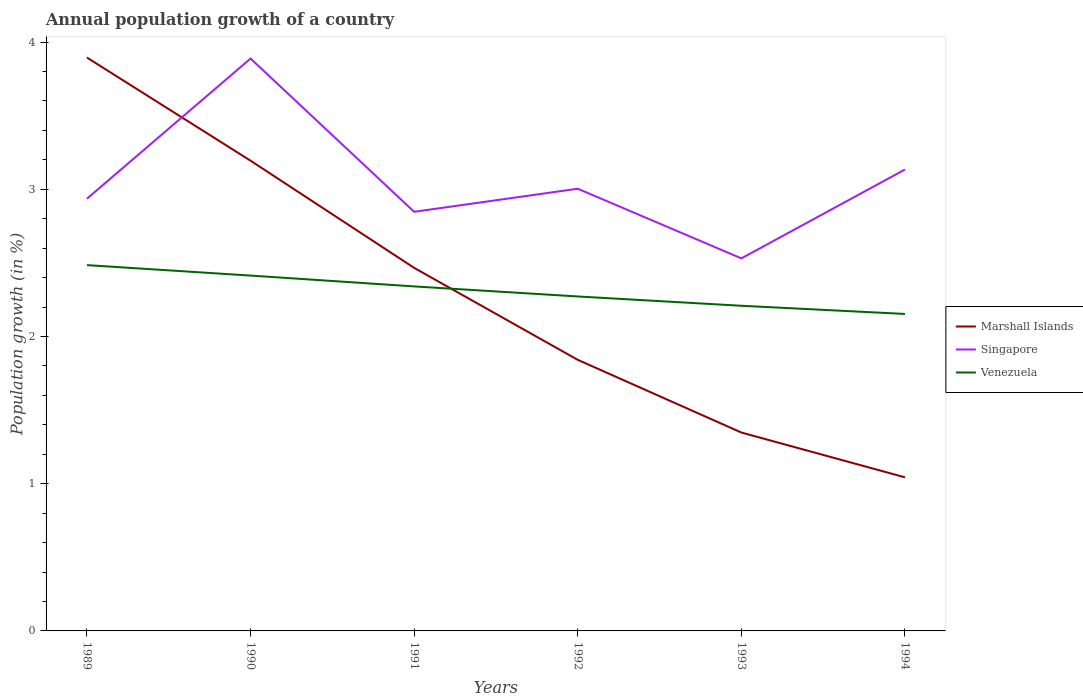Does the line corresponding to Marshall Islands intersect with the line corresponding to Venezuela?
Your response must be concise. Yes. Across all years, what is the maximum annual population growth in Marshall Islands?
Give a very brief answer. 1.04. What is the total annual population growth in Marshall Islands in the graph?
Your response must be concise. 1.12. What is the difference between the highest and the second highest annual population growth in Singapore?
Your answer should be compact. 1.36. What is the difference between the highest and the lowest annual population growth in Marshall Islands?
Your answer should be very brief. 3. How many lines are there?
Provide a succinct answer. 3. What is the difference between two consecutive major ticks on the Y-axis?
Your answer should be compact. 1. Does the graph contain any zero values?
Give a very brief answer. No. Where does the legend appear in the graph?
Your answer should be compact. Center right. What is the title of the graph?
Ensure brevity in your answer.  Annual population growth of a country. Does "Least developed countries" appear as one of the legend labels in the graph?
Offer a very short reply. No. What is the label or title of the X-axis?
Your answer should be very brief. Years. What is the label or title of the Y-axis?
Offer a terse response. Population growth (in %). What is the Population growth (in %) of Marshall Islands in 1989?
Make the answer very short. 3.89. What is the Population growth (in %) in Singapore in 1989?
Your answer should be compact. 2.94. What is the Population growth (in %) in Venezuela in 1989?
Offer a very short reply. 2.48. What is the Population growth (in %) in Marshall Islands in 1990?
Your answer should be compact. 3.19. What is the Population growth (in %) of Singapore in 1990?
Provide a succinct answer. 3.89. What is the Population growth (in %) in Venezuela in 1990?
Your response must be concise. 2.41. What is the Population growth (in %) in Marshall Islands in 1991?
Make the answer very short. 2.47. What is the Population growth (in %) of Singapore in 1991?
Provide a succinct answer. 2.85. What is the Population growth (in %) of Venezuela in 1991?
Provide a succinct answer. 2.34. What is the Population growth (in %) in Marshall Islands in 1992?
Offer a terse response. 1.84. What is the Population growth (in %) in Singapore in 1992?
Provide a succinct answer. 3. What is the Population growth (in %) in Venezuela in 1992?
Your answer should be very brief. 2.27. What is the Population growth (in %) of Marshall Islands in 1993?
Provide a short and direct response. 1.35. What is the Population growth (in %) in Singapore in 1993?
Your response must be concise. 2.53. What is the Population growth (in %) of Venezuela in 1993?
Provide a short and direct response. 2.21. What is the Population growth (in %) of Marshall Islands in 1994?
Offer a very short reply. 1.04. What is the Population growth (in %) of Singapore in 1994?
Keep it short and to the point. 3.13. What is the Population growth (in %) of Venezuela in 1994?
Your answer should be compact. 2.15. Across all years, what is the maximum Population growth (in %) of Marshall Islands?
Give a very brief answer. 3.89. Across all years, what is the maximum Population growth (in %) in Singapore?
Provide a succinct answer. 3.89. Across all years, what is the maximum Population growth (in %) of Venezuela?
Provide a succinct answer. 2.48. Across all years, what is the minimum Population growth (in %) of Marshall Islands?
Make the answer very short. 1.04. Across all years, what is the minimum Population growth (in %) of Singapore?
Keep it short and to the point. 2.53. Across all years, what is the minimum Population growth (in %) in Venezuela?
Provide a succinct answer. 2.15. What is the total Population growth (in %) in Marshall Islands in the graph?
Make the answer very short. 13.79. What is the total Population growth (in %) in Singapore in the graph?
Make the answer very short. 18.34. What is the total Population growth (in %) in Venezuela in the graph?
Your answer should be very brief. 13.87. What is the difference between the Population growth (in %) in Marshall Islands in 1989 and that in 1990?
Make the answer very short. 0.7. What is the difference between the Population growth (in %) of Singapore in 1989 and that in 1990?
Provide a succinct answer. -0.95. What is the difference between the Population growth (in %) in Venezuela in 1989 and that in 1990?
Make the answer very short. 0.07. What is the difference between the Population growth (in %) of Marshall Islands in 1989 and that in 1991?
Give a very brief answer. 1.43. What is the difference between the Population growth (in %) of Singapore in 1989 and that in 1991?
Keep it short and to the point. 0.09. What is the difference between the Population growth (in %) in Venezuela in 1989 and that in 1991?
Provide a short and direct response. 0.14. What is the difference between the Population growth (in %) of Marshall Islands in 1989 and that in 1992?
Your answer should be very brief. 2.05. What is the difference between the Population growth (in %) of Singapore in 1989 and that in 1992?
Provide a short and direct response. -0.07. What is the difference between the Population growth (in %) of Venezuela in 1989 and that in 1992?
Your answer should be very brief. 0.21. What is the difference between the Population growth (in %) of Marshall Islands in 1989 and that in 1993?
Keep it short and to the point. 2.55. What is the difference between the Population growth (in %) of Singapore in 1989 and that in 1993?
Offer a terse response. 0.41. What is the difference between the Population growth (in %) of Venezuela in 1989 and that in 1993?
Keep it short and to the point. 0.28. What is the difference between the Population growth (in %) of Marshall Islands in 1989 and that in 1994?
Your answer should be very brief. 2.85. What is the difference between the Population growth (in %) in Singapore in 1989 and that in 1994?
Your answer should be compact. -0.2. What is the difference between the Population growth (in %) of Venezuela in 1989 and that in 1994?
Provide a short and direct response. 0.33. What is the difference between the Population growth (in %) of Marshall Islands in 1990 and that in 1991?
Provide a succinct answer. 0.73. What is the difference between the Population growth (in %) of Singapore in 1990 and that in 1991?
Give a very brief answer. 1.04. What is the difference between the Population growth (in %) in Venezuela in 1990 and that in 1991?
Ensure brevity in your answer.  0.07. What is the difference between the Population growth (in %) of Marshall Islands in 1990 and that in 1992?
Your answer should be compact. 1.35. What is the difference between the Population growth (in %) of Singapore in 1990 and that in 1992?
Keep it short and to the point. 0.88. What is the difference between the Population growth (in %) of Venezuela in 1990 and that in 1992?
Ensure brevity in your answer.  0.14. What is the difference between the Population growth (in %) of Marshall Islands in 1990 and that in 1993?
Give a very brief answer. 1.85. What is the difference between the Population growth (in %) of Singapore in 1990 and that in 1993?
Provide a short and direct response. 1.36. What is the difference between the Population growth (in %) in Venezuela in 1990 and that in 1993?
Offer a terse response. 0.21. What is the difference between the Population growth (in %) in Marshall Islands in 1990 and that in 1994?
Offer a very short reply. 2.15. What is the difference between the Population growth (in %) of Singapore in 1990 and that in 1994?
Give a very brief answer. 0.75. What is the difference between the Population growth (in %) of Venezuela in 1990 and that in 1994?
Provide a short and direct response. 0.26. What is the difference between the Population growth (in %) in Marshall Islands in 1991 and that in 1992?
Offer a terse response. 0.62. What is the difference between the Population growth (in %) in Singapore in 1991 and that in 1992?
Provide a succinct answer. -0.16. What is the difference between the Population growth (in %) of Venezuela in 1991 and that in 1992?
Make the answer very short. 0.07. What is the difference between the Population growth (in %) in Marshall Islands in 1991 and that in 1993?
Provide a short and direct response. 1.12. What is the difference between the Population growth (in %) in Singapore in 1991 and that in 1993?
Your answer should be compact. 0.32. What is the difference between the Population growth (in %) in Venezuela in 1991 and that in 1993?
Your answer should be very brief. 0.13. What is the difference between the Population growth (in %) of Marshall Islands in 1991 and that in 1994?
Make the answer very short. 1.42. What is the difference between the Population growth (in %) in Singapore in 1991 and that in 1994?
Give a very brief answer. -0.29. What is the difference between the Population growth (in %) in Venezuela in 1991 and that in 1994?
Offer a very short reply. 0.19. What is the difference between the Population growth (in %) of Marshall Islands in 1992 and that in 1993?
Your response must be concise. 0.49. What is the difference between the Population growth (in %) of Singapore in 1992 and that in 1993?
Your answer should be very brief. 0.47. What is the difference between the Population growth (in %) in Venezuela in 1992 and that in 1993?
Keep it short and to the point. 0.06. What is the difference between the Population growth (in %) in Marshall Islands in 1992 and that in 1994?
Give a very brief answer. 0.8. What is the difference between the Population growth (in %) in Singapore in 1992 and that in 1994?
Make the answer very short. -0.13. What is the difference between the Population growth (in %) in Venezuela in 1992 and that in 1994?
Your answer should be very brief. 0.12. What is the difference between the Population growth (in %) of Marshall Islands in 1993 and that in 1994?
Ensure brevity in your answer.  0.3. What is the difference between the Population growth (in %) of Singapore in 1993 and that in 1994?
Your answer should be very brief. -0.6. What is the difference between the Population growth (in %) in Venezuela in 1993 and that in 1994?
Provide a short and direct response. 0.06. What is the difference between the Population growth (in %) in Marshall Islands in 1989 and the Population growth (in %) in Singapore in 1990?
Provide a short and direct response. 0.01. What is the difference between the Population growth (in %) of Marshall Islands in 1989 and the Population growth (in %) of Venezuela in 1990?
Your response must be concise. 1.48. What is the difference between the Population growth (in %) in Singapore in 1989 and the Population growth (in %) in Venezuela in 1990?
Offer a very short reply. 0.52. What is the difference between the Population growth (in %) of Marshall Islands in 1989 and the Population growth (in %) of Singapore in 1991?
Your answer should be very brief. 1.05. What is the difference between the Population growth (in %) in Marshall Islands in 1989 and the Population growth (in %) in Venezuela in 1991?
Provide a succinct answer. 1.55. What is the difference between the Population growth (in %) in Singapore in 1989 and the Population growth (in %) in Venezuela in 1991?
Ensure brevity in your answer.  0.6. What is the difference between the Population growth (in %) of Marshall Islands in 1989 and the Population growth (in %) of Singapore in 1992?
Ensure brevity in your answer.  0.89. What is the difference between the Population growth (in %) of Marshall Islands in 1989 and the Population growth (in %) of Venezuela in 1992?
Your answer should be very brief. 1.62. What is the difference between the Population growth (in %) in Singapore in 1989 and the Population growth (in %) in Venezuela in 1992?
Offer a very short reply. 0.66. What is the difference between the Population growth (in %) of Marshall Islands in 1989 and the Population growth (in %) of Singapore in 1993?
Keep it short and to the point. 1.36. What is the difference between the Population growth (in %) in Marshall Islands in 1989 and the Population growth (in %) in Venezuela in 1993?
Offer a very short reply. 1.69. What is the difference between the Population growth (in %) of Singapore in 1989 and the Population growth (in %) of Venezuela in 1993?
Ensure brevity in your answer.  0.73. What is the difference between the Population growth (in %) of Marshall Islands in 1989 and the Population growth (in %) of Singapore in 1994?
Keep it short and to the point. 0.76. What is the difference between the Population growth (in %) in Marshall Islands in 1989 and the Population growth (in %) in Venezuela in 1994?
Offer a terse response. 1.74. What is the difference between the Population growth (in %) of Singapore in 1989 and the Population growth (in %) of Venezuela in 1994?
Your answer should be very brief. 0.78. What is the difference between the Population growth (in %) of Marshall Islands in 1990 and the Population growth (in %) of Singapore in 1991?
Your answer should be compact. 0.35. What is the difference between the Population growth (in %) of Marshall Islands in 1990 and the Population growth (in %) of Venezuela in 1991?
Your answer should be very brief. 0.85. What is the difference between the Population growth (in %) of Singapore in 1990 and the Population growth (in %) of Venezuela in 1991?
Offer a terse response. 1.55. What is the difference between the Population growth (in %) in Marshall Islands in 1990 and the Population growth (in %) in Singapore in 1992?
Provide a short and direct response. 0.19. What is the difference between the Population growth (in %) of Marshall Islands in 1990 and the Population growth (in %) of Venezuela in 1992?
Give a very brief answer. 0.92. What is the difference between the Population growth (in %) of Singapore in 1990 and the Population growth (in %) of Venezuela in 1992?
Ensure brevity in your answer.  1.62. What is the difference between the Population growth (in %) in Marshall Islands in 1990 and the Population growth (in %) in Singapore in 1993?
Keep it short and to the point. 0.66. What is the difference between the Population growth (in %) of Marshall Islands in 1990 and the Population growth (in %) of Venezuela in 1993?
Your answer should be compact. 0.99. What is the difference between the Population growth (in %) in Singapore in 1990 and the Population growth (in %) in Venezuela in 1993?
Your answer should be compact. 1.68. What is the difference between the Population growth (in %) of Marshall Islands in 1990 and the Population growth (in %) of Singapore in 1994?
Offer a terse response. 0.06. What is the difference between the Population growth (in %) of Marshall Islands in 1990 and the Population growth (in %) of Venezuela in 1994?
Your answer should be very brief. 1.04. What is the difference between the Population growth (in %) of Singapore in 1990 and the Population growth (in %) of Venezuela in 1994?
Offer a very short reply. 1.73. What is the difference between the Population growth (in %) of Marshall Islands in 1991 and the Population growth (in %) of Singapore in 1992?
Give a very brief answer. -0.54. What is the difference between the Population growth (in %) in Marshall Islands in 1991 and the Population growth (in %) in Venezuela in 1992?
Your answer should be compact. 0.19. What is the difference between the Population growth (in %) in Singapore in 1991 and the Population growth (in %) in Venezuela in 1992?
Ensure brevity in your answer.  0.58. What is the difference between the Population growth (in %) in Marshall Islands in 1991 and the Population growth (in %) in Singapore in 1993?
Offer a terse response. -0.06. What is the difference between the Population growth (in %) in Marshall Islands in 1991 and the Population growth (in %) in Venezuela in 1993?
Offer a very short reply. 0.26. What is the difference between the Population growth (in %) in Singapore in 1991 and the Population growth (in %) in Venezuela in 1993?
Your answer should be very brief. 0.64. What is the difference between the Population growth (in %) in Marshall Islands in 1991 and the Population growth (in %) in Singapore in 1994?
Make the answer very short. -0.67. What is the difference between the Population growth (in %) of Marshall Islands in 1991 and the Population growth (in %) of Venezuela in 1994?
Your response must be concise. 0.31. What is the difference between the Population growth (in %) in Singapore in 1991 and the Population growth (in %) in Venezuela in 1994?
Offer a very short reply. 0.69. What is the difference between the Population growth (in %) in Marshall Islands in 1992 and the Population growth (in %) in Singapore in 1993?
Ensure brevity in your answer.  -0.69. What is the difference between the Population growth (in %) of Marshall Islands in 1992 and the Population growth (in %) of Venezuela in 1993?
Provide a short and direct response. -0.37. What is the difference between the Population growth (in %) in Singapore in 1992 and the Population growth (in %) in Venezuela in 1993?
Provide a succinct answer. 0.8. What is the difference between the Population growth (in %) in Marshall Islands in 1992 and the Population growth (in %) in Singapore in 1994?
Give a very brief answer. -1.29. What is the difference between the Population growth (in %) of Marshall Islands in 1992 and the Population growth (in %) of Venezuela in 1994?
Offer a very short reply. -0.31. What is the difference between the Population growth (in %) of Singapore in 1992 and the Population growth (in %) of Venezuela in 1994?
Your response must be concise. 0.85. What is the difference between the Population growth (in %) in Marshall Islands in 1993 and the Population growth (in %) in Singapore in 1994?
Keep it short and to the point. -1.79. What is the difference between the Population growth (in %) in Marshall Islands in 1993 and the Population growth (in %) in Venezuela in 1994?
Your answer should be compact. -0.81. What is the difference between the Population growth (in %) in Singapore in 1993 and the Population growth (in %) in Venezuela in 1994?
Keep it short and to the point. 0.38. What is the average Population growth (in %) of Marshall Islands per year?
Your answer should be compact. 2.3. What is the average Population growth (in %) in Singapore per year?
Provide a succinct answer. 3.06. What is the average Population growth (in %) in Venezuela per year?
Your answer should be very brief. 2.31. In the year 1989, what is the difference between the Population growth (in %) of Marshall Islands and Population growth (in %) of Singapore?
Ensure brevity in your answer.  0.96. In the year 1989, what is the difference between the Population growth (in %) of Marshall Islands and Population growth (in %) of Venezuela?
Your response must be concise. 1.41. In the year 1989, what is the difference between the Population growth (in %) of Singapore and Population growth (in %) of Venezuela?
Give a very brief answer. 0.45. In the year 1990, what is the difference between the Population growth (in %) in Marshall Islands and Population growth (in %) in Singapore?
Provide a short and direct response. -0.69. In the year 1990, what is the difference between the Population growth (in %) of Marshall Islands and Population growth (in %) of Venezuela?
Ensure brevity in your answer.  0.78. In the year 1990, what is the difference between the Population growth (in %) in Singapore and Population growth (in %) in Venezuela?
Your answer should be compact. 1.47. In the year 1991, what is the difference between the Population growth (in %) of Marshall Islands and Population growth (in %) of Singapore?
Provide a short and direct response. -0.38. In the year 1991, what is the difference between the Population growth (in %) of Marshall Islands and Population growth (in %) of Venezuela?
Your answer should be very brief. 0.13. In the year 1991, what is the difference between the Population growth (in %) in Singapore and Population growth (in %) in Venezuela?
Your answer should be very brief. 0.51. In the year 1992, what is the difference between the Population growth (in %) in Marshall Islands and Population growth (in %) in Singapore?
Keep it short and to the point. -1.16. In the year 1992, what is the difference between the Population growth (in %) of Marshall Islands and Population growth (in %) of Venezuela?
Provide a short and direct response. -0.43. In the year 1992, what is the difference between the Population growth (in %) in Singapore and Population growth (in %) in Venezuela?
Ensure brevity in your answer.  0.73. In the year 1993, what is the difference between the Population growth (in %) in Marshall Islands and Population growth (in %) in Singapore?
Provide a short and direct response. -1.18. In the year 1993, what is the difference between the Population growth (in %) in Marshall Islands and Population growth (in %) in Venezuela?
Give a very brief answer. -0.86. In the year 1993, what is the difference between the Population growth (in %) of Singapore and Population growth (in %) of Venezuela?
Your answer should be compact. 0.32. In the year 1994, what is the difference between the Population growth (in %) in Marshall Islands and Population growth (in %) in Singapore?
Ensure brevity in your answer.  -2.09. In the year 1994, what is the difference between the Population growth (in %) of Marshall Islands and Population growth (in %) of Venezuela?
Provide a short and direct response. -1.11. In the year 1994, what is the difference between the Population growth (in %) in Singapore and Population growth (in %) in Venezuela?
Your response must be concise. 0.98. What is the ratio of the Population growth (in %) of Marshall Islands in 1989 to that in 1990?
Give a very brief answer. 1.22. What is the ratio of the Population growth (in %) of Singapore in 1989 to that in 1990?
Your answer should be compact. 0.76. What is the ratio of the Population growth (in %) in Venezuela in 1989 to that in 1990?
Give a very brief answer. 1.03. What is the ratio of the Population growth (in %) in Marshall Islands in 1989 to that in 1991?
Keep it short and to the point. 1.58. What is the ratio of the Population growth (in %) in Singapore in 1989 to that in 1991?
Keep it short and to the point. 1.03. What is the ratio of the Population growth (in %) of Venezuela in 1989 to that in 1991?
Your answer should be compact. 1.06. What is the ratio of the Population growth (in %) in Marshall Islands in 1989 to that in 1992?
Offer a very short reply. 2.12. What is the ratio of the Population growth (in %) in Singapore in 1989 to that in 1992?
Provide a succinct answer. 0.98. What is the ratio of the Population growth (in %) in Venezuela in 1989 to that in 1992?
Provide a short and direct response. 1.09. What is the ratio of the Population growth (in %) of Marshall Islands in 1989 to that in 1993?
Provide a succinct answer. 2.89. What is the ratio of the Population growth (in %) of Singapore in 1989 to that in 1993?
Make the answer very short. 1.16. What is the ratio of the Population growth (in %) of Venezuela in 1989 to that in 1993?
Your response must be concise. 1.12. What is the ratio of the Population growth (in %) of Marshall Islands in 1989 to that in 1994?
Make the answer very short. 3.73. What is the ratio of the Population growth (in %) of Singapore in 1989 to that in 1994?
Your answer should be very brief. 0.94. What is the ratio of the Population growth (in %) of Venezuela in 1989 to that in 1994?
Offer a terse response. 1.15. What is the ratio of the Population growth (in %) in Marshall Islands in 1990 to that in 1991?
Your response must be concise. 1.3. What is the ratio of the Population growth (in %) of Singapore in 1990 to that in 1991?
Give a very brief answer. 1.37. What is the ratio of the Population growth (in %) of Venezuela in 1990 to that in 1991?
Ensure brevity in your answer.  1.03. What is the ratio of the Population growth (in %) in Marshall Islands in 1990 to that in 1992?
Your response must be concise. 1.73. What is the ratio of the Population growth (in %) of Singapore in 1990 to that in 1992?
Give a very brief answer. 1.29. What is the ratio of the Population growth (in %) of Venezuela in 1990 to that in 1992?
Provide a succinct answer. 1.06. What is the ratio of the Population growth (in %) in Marshall Islands in 1990 to that in 1993?
Make the answer very short. 2.37. What is the ratio of the Population growth (in %) in Singapore in 1990 to that in 1993?
Offer a terse response. 1.54. What is the ratio of the Population growth (in %) of Venezuela in 1990 to that in 1993?
Make the answer very short. 1.09. What is the ratio of the Population growth (in %) in Marshall Islands in 1990 to that in 1994?
Keep it short and to the point. 3.06. What is the ratio of the Population growth (in %) of Singapore in 1990 to that in 1994?
Offer a very short reply. 1.24. What is the ratio of the Population growth (in %) in Venezuela in 1990 to that in 1994?
Give a very brief answer. 1.12. What is the ratio of the Population growth (in %) of Marshall Islands in 1991 to that in 1992?
Your response must be concise. 1.34. What is the ratio of the Population growth (in %) of Singapore in 1991 to that in 1992?
Give a very brief answer. 0.95. What is the ratio of the Population growth (in %) of Marshall Islands in 1991 to that in 1993?
Ensure brevity in your answer.  1.83. What is the ratio of the Population growth (in %) of Singapore in 1991 to that in 1993?
Keep it short and to the point. 1.13. What is the ratio of the Population growth (in %) in Venezuela in 1991 to that in 1993?
Keep it short and to the point. 1.06. What is the ratio of the Population growth (in %) of Marshall Islands in 1991 to that in 1994?
Offer a terse response. 2.36. What is the ratio of the Population growth (in %) of Singapore in 1991 to that in 1994?
Your answer should be compact. 0.91. What is the ratio of the Population growth (in %) in Venezuela in 1991 to that in 1994?
Provide a short and direct response. 1.09. What is the ratio of the Population growth (in %) in Marshall Islands in 1992 to that in 1993?
Ensure brevity in your answer.  1.37. What is the ratio of the Population growth (in %) of Singapore in 1992 to that in 1993?
Keep it short and to the point. 1.19. What is the ratio of the Population growth (in %) in Venezuela in 1992 to that in 1993?
Ensure brevity in your answer.  1.03. What is the ratio of the Population growth (in %) in Marshall Islands in 1992 to that in 1994?
Make the answer very short. 1.76. What is the ratio of the Population growth (in %) of Singapore in 1992 to that in 1994?
Make the answer very short. 0.96. What is the ratio of the Population growth (in %) of Venezuela in 1992 to that in 1994?
Make the answer very short. 1.06. What is the ratio of the Population growth (in %) of Marshall Islands in 1993 to that in 1994?
Offer a terse response. 1.29. What is the ratio of the Population growth (in %) in Singapore in 1993 to that in 1994?
Provide a short and direct response. 0.81. What is the ratio of the Population growth (in %) of Venezuela in 1993 to that in 1994?
Your answer should be compact. 1.03. What is the difference between the highest and the second highest Population growth (in %) in Marshall Islands?
Offer a very short reply. 0.7. What is the difference between the highest and the second highest Population growth (in %) of Singapore?
Keep it short and to the point. 0.75. What is the difference between the highest and the second highest Population growth (in %) in Venezuela?
Offer a terse response. 0.07. What is the difference between the highest and the lowest Population growth (in %) in Marshall Islands?
Make the answer very short. 2.85. What is the difference between the highest and the lowest Population growth (in %) in Singapore?
Your answer should be compact. 1.36. What is the difference between the highest and the lowest Population growth (in %) of Venezuela?
Give a very brief answer. 0.33. 